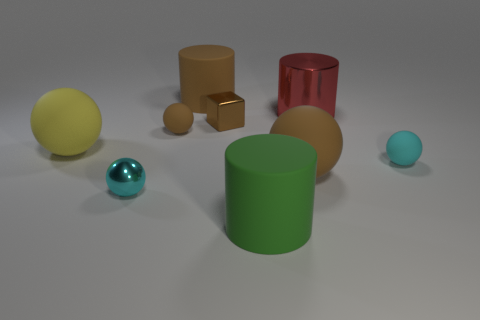Subtract 2 balls. How many balls are left? 3 Subtract all yellow balls. How many balls are left? 4 Subtract all metal spheres. How many spheres are left? 4 Subtract all red spheres. Subtract all blue blocks. How many spheres are left? 5 Add 1 small brown matte cubes. How many objects exist? 10 Subtract all cubes. How many objects are left? 8 Subtract all big red balls. Subtract all rubber cylinders. How many objects are left? 7 Add 3 big yellow rubber things. How many big yellow rubber things are left? 4 Add 1 small brown balls. How many small brown balls exist? 2 Subtract 0 red spheres. How many objects are left? 9 